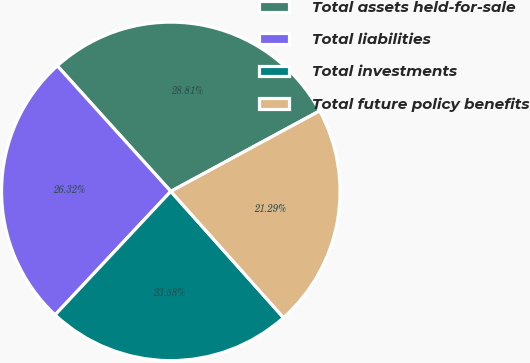Convert chart. <chart><loc_0><loc_0><loc_500><loc_500><pie_chart><fcel>Total assets held-for-sale<fcel>Total liabilities<fcel>Total investments<fcel>Total future policy benefits<nl><fcel>28.81%<fcel>26.32%<fcel>23.58%<fcel>21.29%<nl></chart> 